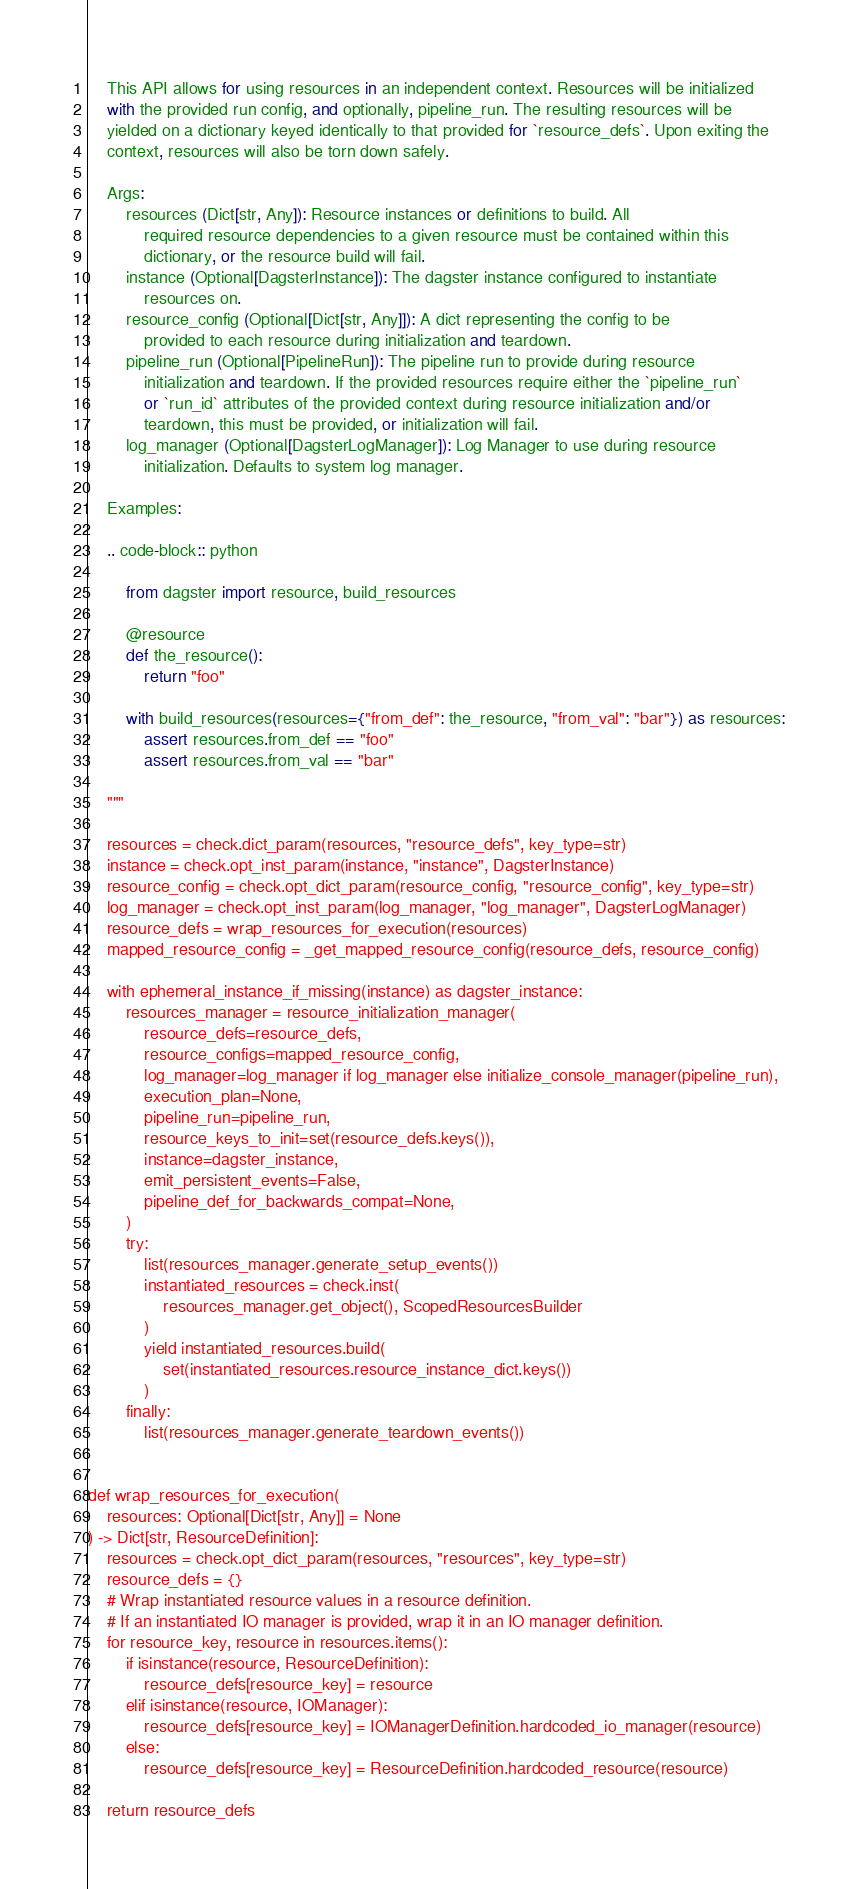Convert code to text. <code><loc_0><loc_0><loc_500><loc_500><_Python_>    This API allows for using resources in an independent context. Resources will be initialized
    with the provided run config, and optionally, pipeline_run. The resulting resources will be
    yielded on a dictionary keyed identically to that provided for `resource_defs`. Upon exiting the
    context, resources will also be torn down safely.

    Args:
        resources (Dict[str, Any]): Resource instances or definitions to build. All
            required resource dependencies to a given resource must be contained within this
            dictionary, or the resource build will fail.
        instance (Optional[DagsterInstance]): The dagster instance configured to instantiate
            resources on.
        resource_config (Optional[Dict[str, Any]]): A dict representing the config to be
            provided to each resource during initialization and teardown.
        pipeline_run (Optional[PipelineRun]): The pipeline run to provide during resource
            initialization and teardown. If the provided resources require either the `pipeline_run`
            or `run_id` attributes of the provided context during resource initialization and/or
            teardown, this must be provided, or initialization will fail.
        log_manager (Optional[DagsterLogManager]): Log Manager to use during resource
            initialization. Defaults to system log manager.

    Examples:

    .. code-block:: python

        from dagster import resource, build_resources

        @resource
        def the_resource():
            return "foo"

        with build_resources(resources={"from_def": the_resource, "from_val": "bar"}) as resources:
            assert resources.from_def == "foo"
            assert resources.from_val == "bar"

    """

    resources = check.dict_param(resources, "resource_defs", key_type=str)
    instance = check.opt_inst_param(instance, "instance", DagsterInstance)
    resource_config = check.opt_dict_param(resource_config, "resource_config", key_type=str)
    log_manager = check.opt_inst_param(log_manager, "log_manager", DagsterLogManager)
    resource_defs = wrap_resources_for_execution(resources)
    mapped_resource_config = _get_mapped_resource_config(resource_defs, resource_config)

    with ephemeral_instance_if_missing(instance) as dagster_instance:
        resources_manager = resource_initialization_manager(
            resource_defs=resource_defs,
            resource_configs=mapped_resource_config,
            log_manager=log_manager if log_manager else initialize_console_manager(pipeline_run),
            execution_plan=None,
            pipeline_run=pipeline_run,
            resource_keys_to_init=set(resource_defs.keys()),
            instance=dagster_instance,
            emit_persistent_events=False,
            pipeline_def_for_backwards_compat=None,
        )
        try:
            list(resources_manager.generate_setup_events())
            instantiated_resources = check.inst(
                resources_manager.get_object(), ScopedResourcesBuilder
            )
            yield instantiated_resources.build(
                set(instantiated_resources.resource_instance_dict.keys())
            )
        finally:
            list(resources_manager.generate_teardown_events())


def wrap_resources_for_execution(
    resources: Optional[Dict[str, Any]] = None
) -> Dict[str, ResourceDefinition]:
    resources = check.opt_dict_param(resources, "resources", key_type=str)
    resource_defs = {}
    # Wrap instantiated resource values in a resource definition.
    # If an instantiated IO manager is provided, wrap it in an IO manager definition.
    for resource_key, resource in resources.items():
        if isinstance(resource, ResourceDefinition):
            resource_defs[resource_key] = resource
        elif isinstance(resource, IOManager):
            resource_defs[resource_key] = IOManagerDefinition.hardcoded_io_manager(resource)
        else:
            resource_defs[resource_key] = ResourceDefinition.hardcoded_resource(resource)

    return resource_defs
</code> 